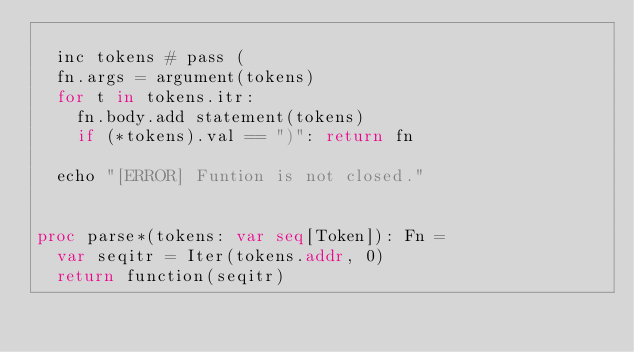Convert code to text. <code><loc_0><loc_0><loc_500><loc_500><_Nim_>  
  inc tokens # pass (
  fn.args = argument(tokens)
  for t in tokens.itr:
    fn.body.add statement(tokens)
    if (*tokens).val == ")": return fn

  echo "[ERROR] Funtion is not closed."


proc parse*(tokens: var seq[Token]): Fn =
  var seqitr = Iter(tokens.addr, 0)
  return function(seqitr)
</code> 